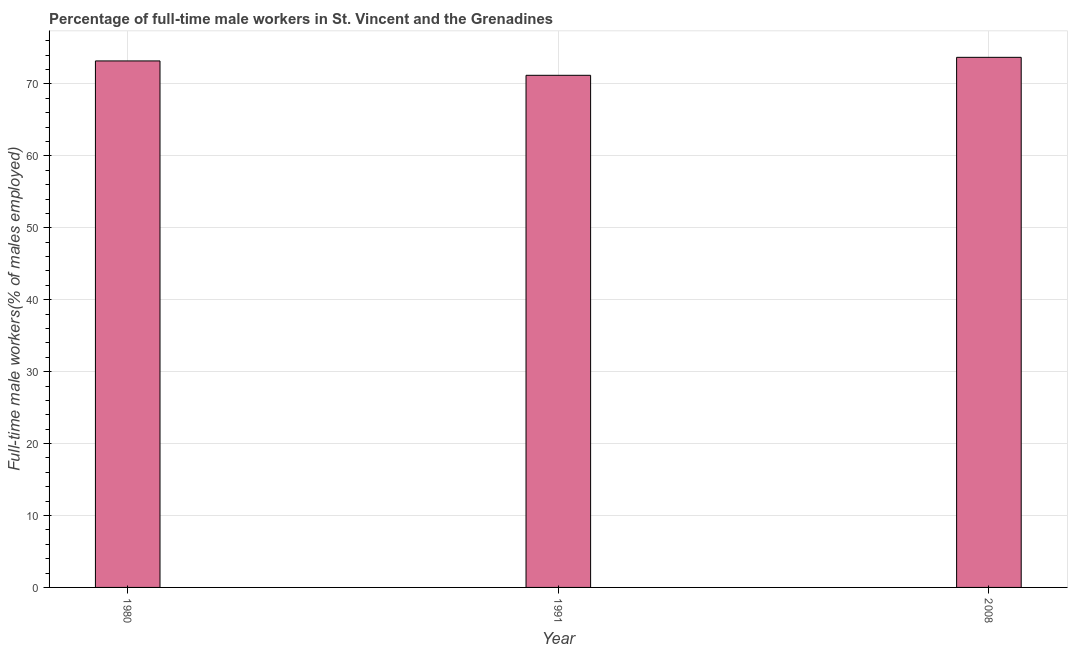Does the graph contain any zero values?
Your response must be concise. No. What is the title of the graph?
Give a very brief answer. Percentage of full-time male workers in St. Vincent and the Grenadines. What is the label or title of the X-axis?
Provide a succinct answer. Year. What is the label or title of the Y-axis?
Your answer should be compact. Full-time male workers(% of males employed). What is the percentage of full-time male workers in 1980?
Provide a succinct answer. 73.2. Across all years, what is the maximum percentage of full-time male workers?
Offer a terse response. 73.7. Across all years, what is the minimum percentage of full-time male workers?
Make the answer very short. 71.2. In which year was the percentage of full-time male workers maximum?
Offer a very short reply. 2008. What is the sum of the percentage of full-time male workers?
Your response must be concise. 218.1. What is the difference between the percentage of full-time male workers in 1991 and 2008?
Your answer should be very brief. -2.5. What is the average percentage of full-time male workers per year?
Your answer should be very brief. 72.7. What is the median percentage of full-time male workers?
Offer a very short reply. 73.2. Do a majority of the years between 1991 and 2008 (inclusive) have percentage of full-time male workers greater than 12 %?
Provide a short and direct response. Yes. What is the ratio of the percentage of full-time male workers in 1980 to that in 1991?
Keep it short and to the point. 1.03. Is the difference between the percentage of full-time male workers in 1980 and 2008 greater than the difference between any two years?
Give a very brief answer. No. Is the sum of the percentage of full-time male workers in 1980 and 2008 greater than the maximum percentage of full-time male workers across all years?
Provide a succinct answer. Yes. In how many years, is the percentage of full-time male workers greater than the average percentage of full-time male workers taken over all years?
Your response must be concise. 2. How many years are there in the graph?
Ensure brevity in your answer.  3. What is the difference between two consecutive major ticks on the Y-axis?
Keep it short and to the point. 10. Are the values on the major ticks of Y-axis written in scientific E-notation?
Offer a terse response. No. What is the Full-time male workers(% of males employed) of 1980?
Your response must be concise. 73.2. What is the Full-time male workers(% of males employed) of 1991?
Offer a very short reply. 71.2. What is the Full-time male workers(% of males employed) of 2008?
Give a very brief answer. 73.7. What is the difference between the Full-time male workers(% of males employed) in 1980 and 1991?
Offer a terse response. 2. What is the ratio of the Full-time male workers(% of males employed) in 1980 to that in 1991?
Keep it short and to the point. 1.03. What is the ratio of the Full-time male workers(% of males employed) in 1991 to that in 2008?
Keep it short and to the point. 0.97. 